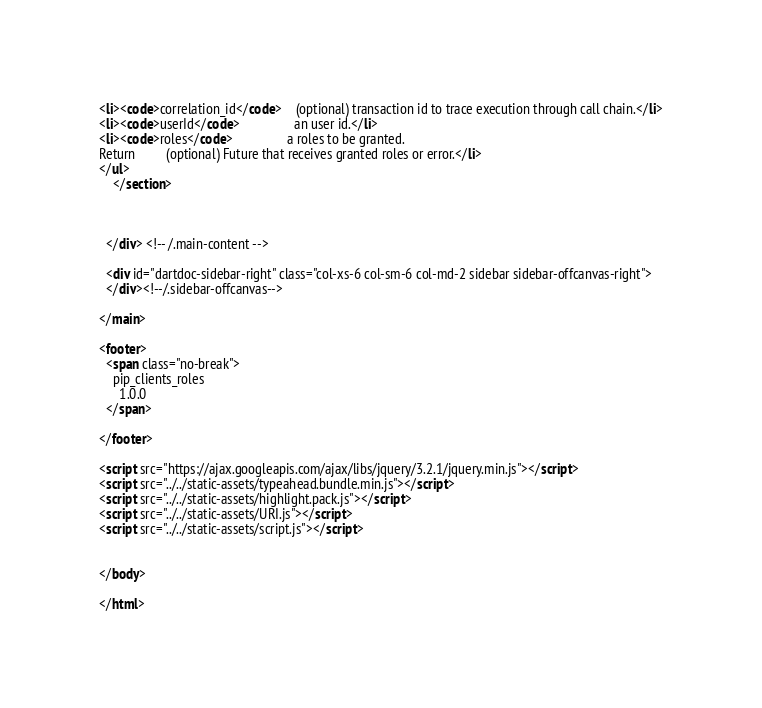Convert code to text. <code><loc_0><loc_0><loc_500><loc_500><_HTML_><li><code>correlation_id</code>    (optional) transaction id to trace execution through call chain.</li>
<li><code>userId</code>                an user id.</li>
<li><code>roles</code>                a roles to be granted.
Return         (optional) Future that receives granted roles or error.</li>
</ul>
    </section>
    
    

  </div> <!-- /.main-content -->

  <div id="dartdoc-sidebar-right" class="col-xs-6 col-sm-6 col-md-2 sidebar sidebar-offcanvas-right">
  </div><!--/.sidebar-offcanvas-->

</main>

<footer>
  <span class="no-break">
    pip_clients_roles
      1.0.0
  </span>

</footer>

<script src="https://ajax.googleapis.com/ajax/libs/jquery/3.2.1/jquery.min.js"></script>
<script src="../../static-assets/typeahead.bundle.min.js"></script>
<script src="../../static-assets/highlight.pack.js"></script>
<script src="../../static-assets/URI.js"></script>
<script src="../../static-assets/script.js"></script>


</body>

</html>
</code> 